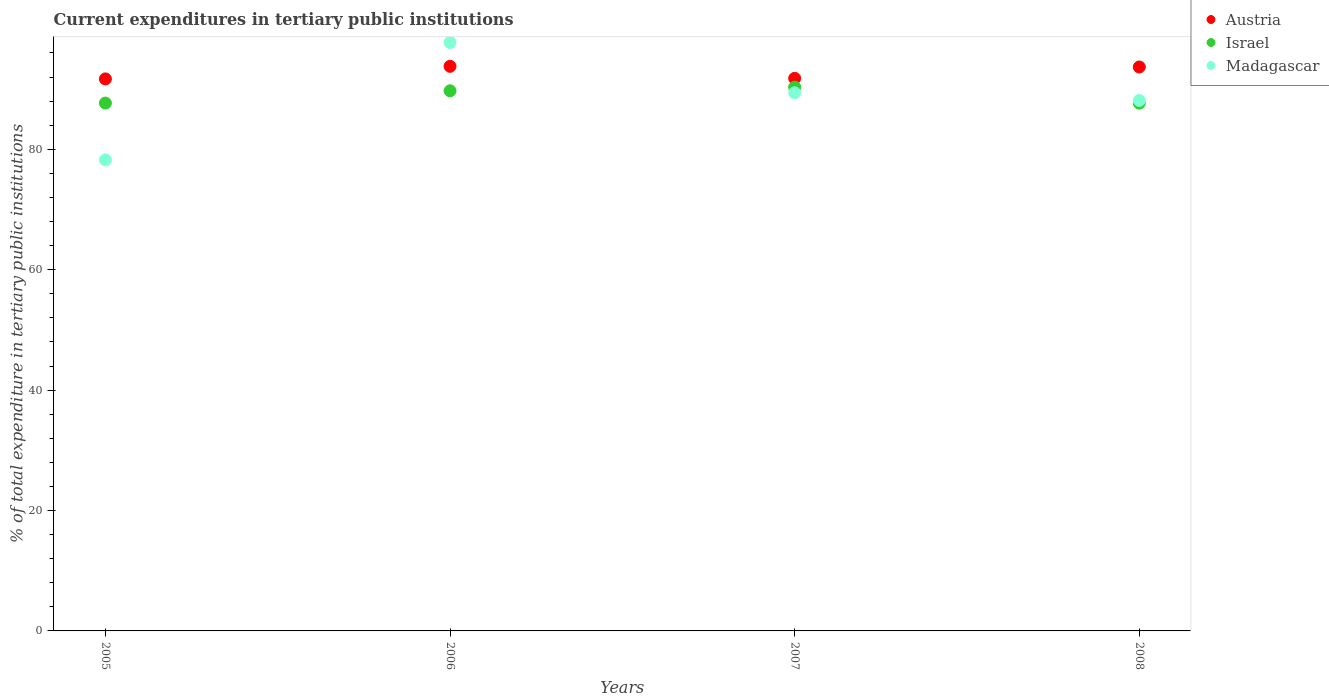Is the number of dotlines equal to the number of legend labels?
Make the answer very short. Yes. What is the current expenditures in tertiary public institutions in Israel in 2008?
Your answer should be compact. 87.67. Across all years, what is the maximum current expenditures in tertiary public institutions in Austria?
Ensure brevity in your answer.  93.78. Across all years, what is the minimum current expenditures in tertiary public institutions in Madagascar?
Offer a terse response. 78.25. In which year was the current expenditures in tertiary public institutions in Madagascar maximum?
Keep it short and to the point. 2006. In which year was the current expenditures in tertiary public institutions in Israel minimum?
Your response must be concise. 2008. What is the total current expenditures in tertiary public institutions in Israel in the graph?
Your response must be concise. 355.4. What is the difference between the current expenditures in tertiary public institutions in Israel in 2006 and that in 2007?
Your response must be concise. -0.61. What is the difference between the current expenditures in tertiary public institutions in Madagascar in 2006 and the current expenditures in tertiary public institutions in Austria in 2008?
Give a very brief answer. 4.07. What is the average current expenditures in tertiary public institutions in Madagascar per year?
Your answer should be compact. 88.37. In the year 2008, what is the difference between the current expenditures in tertiary public institutions in Madagascar and current expenditures in tertiary public institutions in Austria?
Offer a terse response. -5.57. In how many years, is the current expenditures in tertiary public institutions in Madagascar greater than 56 %?
Provide a succinct answer. 4. What is the ratio of the current expenditures in tertiary public institutions in Madagascar in 2006 to that in 2007?
Your answer should be very brief. 1.09. Is the difference between the current expenditures in tertiary public institutions in Madagascar in 2006 and 2008 greater than the difference between the current expenditures in tertiary public institutions in Austria in 2006 and 2008?
Give a very brief answer. Yes. What is the difference between the highest and the second highest current expenditures in tertiary public institutions in Madagascar?
Your response must be concise. 8.36. What is the difference between the highest and the lowest current expenditures in tertiary public institutions in Israel?
Your answer should be very brief. 2.67. Is the sum of the current expenditures in tertiary public institutions in Madagascar in 2005 and 2007 greater than the maximum current expenditures in tertiary public institutions in Austria across all years?
Provide a succinct answer. Yes. Is it the case that in every year, the sum of the current expenditures in tertiary public institutions in Israel and current expenditures in tertiary public institutions in Austria  is greater than the current expenditures in tertiary public institutions in Madagascar?
Your answer should be compact. Yes. Does the current expenditures in tertiary public institutions in Israel monotonically increase over the years?
Provide a short and direct response. No. Is the current expenditures in tertiary public institutions in Israel strictly less than the current expenditures in tertiary public institutions in Madagascar over the years?
Give a very brief answer. No. How many dotlines are there?
Offer a terse response. 3. How many years are there in the graph?
Your answer should be very brief. 4. What is the difference between two consecutive major ticks on the Y-axis?
Provide a succinct answer. 20. Are the values on the major ticks of Y-axis written in scientific E-notation?
Provide a short and direct response. No. Does the graph contain grids?
Your response must be concise. No. How are the legend labels stacked?
Your response must be concise. Vertical. What is the title of the graph?
Your answer should be very brief. Current expenditures in tertiary public institutions. Does "Tajikistan" appear as one of the legend labels in the graph?
Your answer should be compact. No. What is the label or title of the X-axis?
Ensure brevity in your answer.  Years. What is the label or title of the Y-axis?
Your answer should be very brief. % of total expenditure in tertiary public institutions. What is the % of total expenditure in tertiary public institutions in Austria in 2005?
Offer a terse response. 91.69. What is the % of total expenditure in tertiary public institutions of Israel in 2005?
Offer a very short reply. 87.68. What is the % of total expenditure in tertiary public institutions in Madagascar in 2005?
Your answer should be very brief. 78.25. What is the % of total expenditure in tertiary public institutions of Austria in 2006?
Offer a very short reply. 93.78. What is the % of total expenditure in tertiary public institutions of Israel in 2006?
Provide a short and direct response. 89.72. What is the % of total expenditure in tertiary public institutions of Madagascar in 2006?
Your response must be concise. 97.75. What is the % of total expenditure in tertiary public institutions of Austria in 2007?
Make the answer very short. 91.79. What is the % of total expenditure in tertiary public institutions of Israel in 2007?
Offer a very short reply. 90.33. What is the % of total expenditure in tertiary public institutions of Madagascar in 2007?
Your answer should be compact. 89.39. What is the % of total expenditure in tertiary public institutions of Austria in 2008?
Offer a very short reply. 93.68. What is the % of total expenditure in tertiary public institutions of Israel in 2008?
Ensure brevity in your answer.  87.67. What is the % of total expenditure in tertiary public institutions in Madagascar in 2008?
Your response must be concise. 88.11. Across all years, what is the maximum % of total expenditure in tertiary public institutions of Austria?
Your response must be concise. 93.78. Across all years, what is the maximum % of total expenditure in tertiary public institutions of Israel?
Provide a short and direct response. 90.33. Across all years, what is the maximum % of total expenditure in tertiary public institutions in Madagascar?
Provide a short and direct response. 97.75. Across all years, what is the minimum % of total expenditure in tertiary public institutions in Austria?
Give a very brief answer. 91.69. Across all years, what is the minimum % of total expenditure in tertiary public institutions of Israel?
Ensure brevity in your answer.  87.67. Across all years, what is the minimum % of total expenditure in tertiary public institutions in Madagascar?
Make the answer very short. 78.25. What is the total % of total expenditure in tertiary public institutions of Austria in the graph?
Give a very brief answer. 370.94. What is the total % of total expenditure in tertiary public institutions in Israel in the graph?
Your response must be concise. 355.4. What is the total % of total expenditure in tertiary public institutions in Madagascar in the graph?
Provide a succinct answer. 353.49. What is the difference between the % of total expenditure in tertiary public institutions of Austria in 2005 and that in 2006?
Provide a short and direct response. -2.09. What is the difference between the % of total expenditure in tertiary public institutions in Israel in 2005 and that in 2006?
Your answer should be very brief. -2.04. What is the difference between the % of total expenditure in tertiary public institutions in Madagascar in 2005 and that in 2006?
Give a very brief answer. -19.5. What is the difference between the % of total expenditure in tertiary public institutions of Austria in 2005 and that in 2007?
Your answer should be compact. -0.09. What is the difference between the % of total expenditure in tertiary public institutions of Israel in 2005 and that in 2007?
Your answer should be very brief. -2.65. What is the difference between the % of total expenditure in tertiary public institutions in Madagascar in 2005 and that in 2007?
Offer a terse response. -11.15. What is the difference between the % of total expenditure in tertiary public institutions of Austria in 2005 and that in 2008?
Keep it short and to the point. -1.98. What is the difference between the % of total expenditure in tertiary public institutions in Israel in 2005 and that in 2008?
Your answer should be very brief. 0.01. What is the difference between the % of total expenditure in tertiary public institutions in Madagascar in 2005 and that in 2008?
Your answer should be very brief. -9.86. What is the difference between the % of total expenditure in tertiary public institutions in Austria in 2006 and that in 2007?
Provide a short and direct response. 2. What is the difference between the % of total expenditure in tertiary public institutions in Israel in 2006 and that in 2007?
Your answer should be compact. -0.61. What is the difference between the % of total expenditure in tertiary public institutions of Madagascar in 2006 and that in 2007?
Your answer should be compact. 8.36. What is the difference between the % of total expenditure in tertiary public institutions of Austria in 2006 and that in 2008?
Your response must be concise. 0.11. What is the difference between the % of total expenditure in tertiary public institutions in Israel in 2006 and that in 2008?
Your answer should be compact. 2.05. What is the difference between the % of total expenditure in tertiary public institutions of Madagascar in 2006 and that in 2008?
Give a very brief answer. 9.64. What is the difference between the % of total expenditure in tertiary public institutions of Austria in 2007 and that in 2008?
Offer a very short reply. -1.89. What is the difference between the % of total expenditure in tertiary public institutions in Israel in 2007 and that in 2008?
Offer a terse response. 2.67. What is the difference between the % of total expenditure in tertiary public institutions of Madagascar in 2007 and that in 2008?
Offer a very short reply. 1.28. What is the difference between the % of total expenditure in tertiary public institutions in Austria in 2005 and the % of total expenditure in tertiary public institutions in Israel in 2006?
Ensure brevity in your answer.  1.97. What is the difference between the % of total expenditure in tertiary public institutions of Austria in 2005 and the % of total expenditure in tertiary public institutions of Madagascar in 2006?
Provide a succinct answer. -6.06. What is the difference between the % of total expenditure in tertiary public institutions in Israel in 2005 and the % of total expenditure in tertiary public institutions in Madagascar in 2006?
Ensure brevity in your answer.  -10.07. What is the difference between the % of total expenditure in tertiary public institutions of Austria in 2005 and the % of total expenditure in tertiary public institutions of Israel in 2007?
Provide a short and direct response. 1.36. What is the difference between the % of total expenditure in tertiary public institutions of Austria in 2005 and the % of total expenditure in tertiary public institutions of Madagascar in 2007?
Provide a short and direct response. 2.3. What is the difference between the % of total expenditure in tertiary public institutions in Israel in 2005 and the % of total expenditure in tertiary public institutions in Madagascar in 2007?
Make the answer very short. -1.71. What is the difference between the % of total expenditure in tertiary public institutions of Austria in 2005 and the % of total expenditure in tertiary public institutions of Israel in 2008?
Keep it short and to the point. 4.03. What is the difference between the % of total expenditure in tertiary public institutions of Austria in 2005 and the % of total expenditure in tertiary public institutions of Madagascar in 2008?
Keep it short and to the point. 3.59. What is the difference between the % of total expenditure in tertiary public institutions of Israel in 2005 and the % of total expenditure in tertiary public institutions of Madagascar in 2008?
Give a very brief answer. -0.43. What is the difference between the % of total expenditure in tertiary public institutions of Austria in 2006 and the % of total expenditure in tertiary public institutions of Israel in 2007?
Your response must be concise. 3.45. What is the difference between the % of total expenditure in tertiary public institutions in Austria in 2006 and the % of total expenditure in tertiary public institutions in Madagascar in 2007?
Your response must be concise. 4.39. What is the difference between the % of total expenditure in tertiary public institutions in Israel in 2006 and the % of total expenditure in tertiary public institutions in Madagascar in 2007?
Your response must be concise. 0.33. What is the difference between the % of total expenditure in tertiary public institutions in Austria in 2006 and the % of total expenditure in tertiary public institutions in Israel in 2008?
Ensure brevity in your answer.  6.12. What is the difference between the % of total expenditure in tertiary public institutions in Austria in 2006 and the % of total expenditure in tertiary public institutions in Madagascar in 2008?
Keep it short and to the point. 5.68. What is the difference between the % of total expenditure in tertiary public institutions in Israel in 2006 and the % of total expenditure in tertiary public institutions in Madagascar in 2008?
Give a very brief answer. 1.61. What is the difference between the % of total expenditure in tertiary public institutions of Austria in 2007 and the % of total expenditure in tertiary public institutions of Israel in 2008?
Your answer should be very brief. 4.12. What is the difference between the % of total expenditure in tertiary public institutions of Austria in 2007 and the % of total expenditure in tertiary public institutions of Madagascar in 2008?
Offer a very short reply. 3.68. What is the difference between the % of total expenditure in tertiary public institutions in Israel in 2007 and the % of total expenditure in tertiary public institutions in Madagascar in 2008?
Your answer should be very brief. 2.23. What is the average % of total expenditure in tertiary public institutions in Austria per year?
Your answer should be very brief. 92.74. What is the average % of total expenditure in tertiary public institutions of Israel per year?
Give a very brief answer. 88.85. What is the average % of total expenditure in tertiary public institutions in Madagascar per year?
Give a very brief answer. 88.37. In the year 2005, what is the difference between the % of total expenditure in tertiary public institutions of Austria and % of total expenditure in tertiary public institutions of Israel?
Provide a succinct answer. 4.02. In the year 2005, what is the difference between the % of total expenditure in tertiary public institutions of Austria and % of total expenditure in tertiary public institutions of Madagascar?
Give a very brief answer. 13.45. In the year 2005, what is the difference between the % of total expenditure in tertiary public institutions of Israel and % of total expenditure in tertiary public institutions of Madagascar?
Provide a short and direct response. 9.43. In the year 2006, what is the difference between the % of total expenditure in tertiary public institutions of Austria and % of total expenditure in tertiary public institutions of Israel?
Keep it short and to the point. 4.06. In the year 2006, what is the difference between the % of total expenditure in tertiary public institutions of Austria and % of total expenditure in tertiary public institutions of Madagascar?
Your answer should be very brief. -3.97. In the year 2006, what is the difference between the % of total expenditure in tertiary public institutions in Israel and % of total expenditure in tertiary public institutions in Madagascar?
Your response must be concise. -8.03. In the year 2007, what is the difference between the % of total expenditure in tertiary public institutions in Austria and % of total expenditure in tertiary public institutions in Israel?
Your answer should be very brief. 1.45. In the year 2007, what is the difference between the % of total expenditure in tertiary public institutions of Austria and % of total expenditure in tertiary public institutions of Madagascar?
Your answer should be compact. 2.4. In the year 2007, what is the difference between the % of total expenditure in tertiary public institutions of Israel and % of total expenditure in tertiary public institutions of Madagascar?
Offer a very short reply. 0.94. In the year 2008, what is the difference between the % of total expenditure in tertiary public institutions in Austria and % of total expenditure in tertiary public institutions in Israel?
Provide a short and direct response. 6.01. In the year 2008, what is the difference between the % of total expenditure in tertiary public institutions in Austria and % of total expenditure in tertiary public institutions in Madagascar?
Your answer should be very brief. 5.57. In the year 2008, what is the difference between the % of total expenditure in tertiary public institutions of Israel and % of total expenditure in tertiary public institutions of Madagascar?
Provide a short and direct response. -0.44. What is the ratio of the % of total expenditure in tertiary public institutions in Austria in 2005 to that in 2006?
Offer a very short reply. 0.98. What is the ratio of the % of total expenditure in tertiary public institutions in Israel in 2005 to that in 2006?
Provide a succinct answer. 0.98. What is the ratio of the % of total expenditure in tertiary public institutions of Madagascar in 2005 to that in 2006?
Offer a terse response. 0.8. What is the ratio of the % of total expenditure in tertiary public institutions of Israel in 2005 to that in 2007?
Offer a terse response. 0.97. What is the ratio of the % of total expenditure in tertiary public institutions in Madagascar in 2005 to that in 2007?
Make the answer very short. 0.88. What is the ratio of the % of total expenditure in tertiary public institutions in Austria in 2005 to that in 2008?
Make the answer very short. 0.98. What is the ratio of the % of total expenditure in tertiary public institutions of Madagascar in 2005 to that in 2008?
Offer a very short reply. 0.89. What is the ratio of the % of total expenditure in tertiary public institutions in Austria in 2006 to that in 2007?
Offer a very short reply. 1.02. What is the ratio of the % of total expenditure in tertiary public institutions of Madagascar in 2006 to that in 2007?
Offer a terse response. 1.09. What is the ratio of the % of total expenditure in tertiary public institutions in Israel in 2006 to that in 2008?
Keep it short and to the point. 1.02. What is the ratio of the % of total expenditure in tertiary public institutions of Madagascar in 2006 to that in 2008?
Ensure brevity in your answer.  1.11. What is the ratio of the % of total expenditure in tertiary public institutions of Austria in 2007 to that in 2008?
Offer a very short reply. 0.98. What is the ratio of the % of total expenditure in tertiary public institutions of Israel in 2007 to that in 2008?
Your answer should be compact. 1.03. What is the ratio of the % of total expenditure in tertiary public institutions in Madagascar in 2007 to that in 2008?
Give a very brief answer. 1.01. What is the difference between the highest and the second highest % of total expenditure in tertiary public institutions of Austria?
Give a very brief answer. 0.11. What is the difference between the highest and the second highest % of total expenditure in tertiary public institutions of Israel?
Your answer should be very brief. 0.61. What is the difference between the highest and the second highest % of total expenditure in tertiary public institutions of Madagascar?
Offer a terse response. 8.36. What is the difference between the highest and the lowest % of total expenditure in tertiary public institutions in Austria?
Provide a succinct answer. 2.09. What is the difference between the highest and the lowest % of total expenditure in tertiary public institutions of Israel?
Ensure brevity in your answer.  2.67. What is the difference between the highest and the lowest % of total expenditure in tertiary public institutions of Madagascar?
Keep it short and to the point. 19.5. 